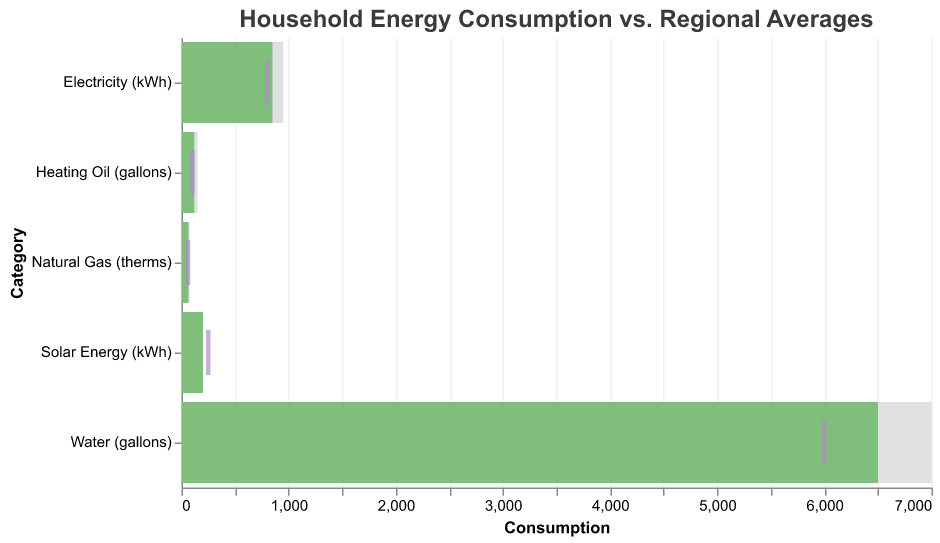what is the title of the figure? The title of the figure is clearly labeled at the top, indicating the theme of the visualization. The text reads "Household Energy Consumption vs. Regional Averages"
Answer: Household Energy Consumption vs. Regional Averages How many categories are presented in the figure? The figure shows data for different types of household energy consumption across five categories, which can be easily counted by looking at the y-axis. The categories are Electricity, Natural Gas, Water, Heating Oil, and Solar Energy.
Answer: 5 Which category has the highest actual consumption? By examining the bars representing the actual consumption, we can see that "Water (gallons)" has the longest bar on the x-axis, indicating it has the highest actual consumption among the categories.
Answer: Water (gallons) What color represents the target in the figure? The target values are shown as tick marks, which are colored distinctly from the bars. These tick marks are colored medium purple, which helps differentiate them from the actual and regional average consumption.
Answer: Medium Purple What is the difference between the actual and target consumption for Heating Oil? Look at the bar and tick mark for Heating Oil to subtract the target from the actual value (Actual value: 120 gallons, Target value: 100 gallons). 120 - 100 = 20 gallons.
Answer: 20 gallons Which categories have actual consumption greater than the regional average? Compare the lengths of the actual consumption bars to the lengths of the regional average bars. The categories where the actual consumption bars exceed the regional average bars are Electricity and Solar Energy.
Answer: Electricity and Solar Energy For which category is the target value higher than the actual consumption? Look at the tick marks (targets) and bars (actual consumption). The Solar Energy category has a target (250 kWh) that is higher than its actual consumption (200 kWh)
Answer: Solar Energy What is the average of the target values across all categories? To find the average target value, add all target values (800 + 60 + 6000 + 100 + 250 = 7210) and then divide by the number of categories, which is 5. 7210 / 5 = 1442
Answer: 1442 How much more natural gas does the household consume compared to the target? The household consumes 65 therms of natural gas compared to a target of 60 therms. Subtract the target from the actual: 65 - 60 = 5 therms.
Answer: 5 therms Is the household's water consumption above or below the regional average? By comparing the actual bar (6500 gallons) to the regional average bar (7000 gallons), it is clear that the household's water consumption is below the regional average.
Answer: Below 